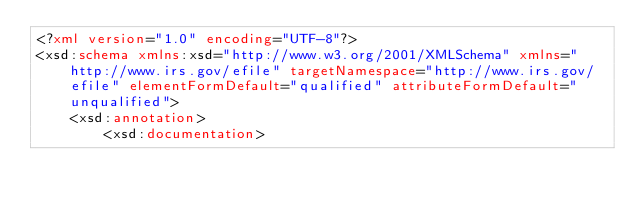<code> <loc_0><loc_0><loc_500><loc_500><_XML_><?xml version="1.0" encoding="UTF-8"?>
<xsd:schema xmlns:xsd="http://www.w3.org/2001/XMLSchema" xmlns="http://www.irs.gov/efile" targetNamespace="http://www.irs.gov/efile" elementFormDefault="qualified" attributeFormDefault="unqualified">
	<xsd:annotation>
		<xsd:documentation></code> 